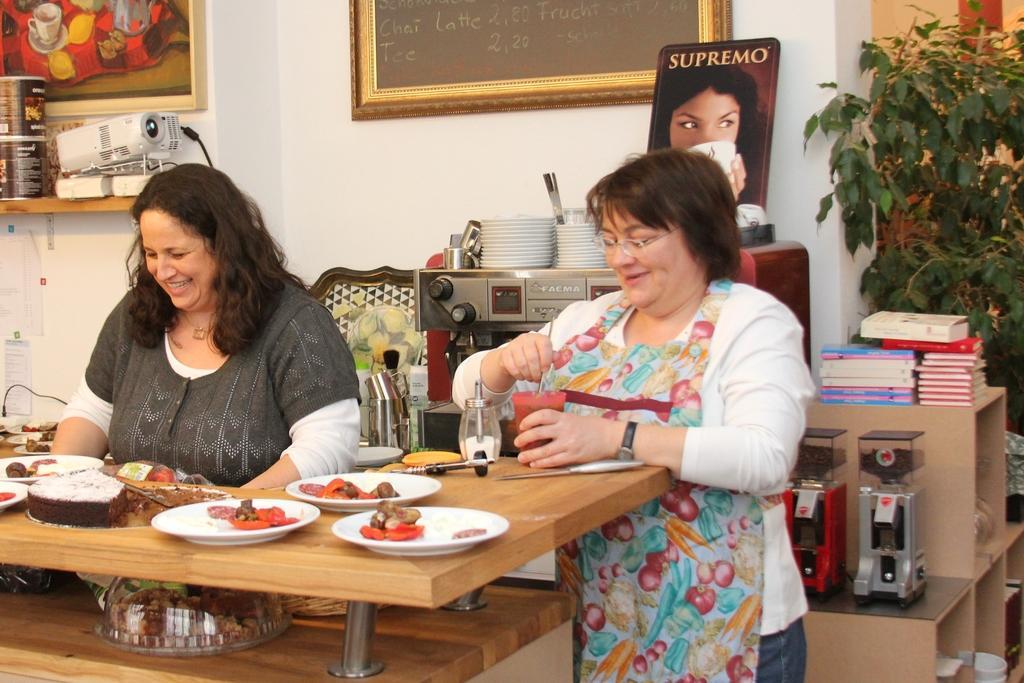Describe this image in one or two sentences. In this image i can see two women and there are some food items on the table at the background of the image there are books,plants,paintings and projector. 